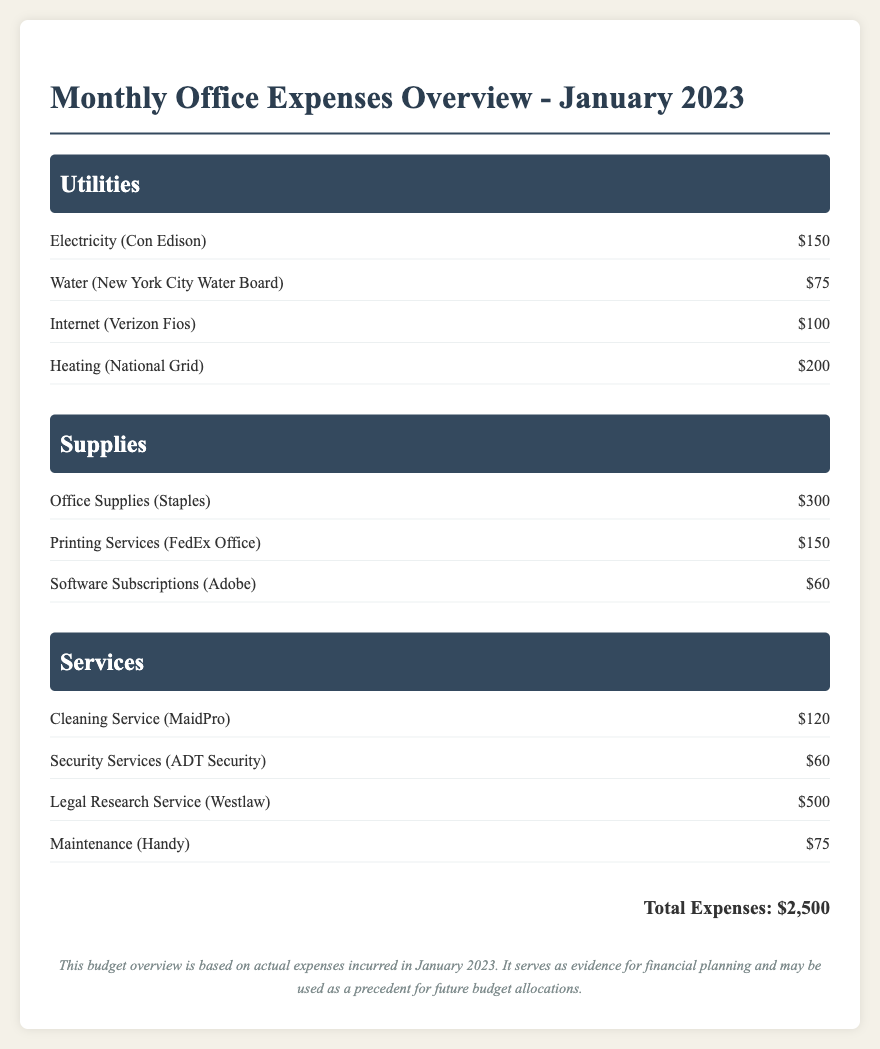What was the expense for electricity? The expense for electricity can be found listed under Utilities as $150.
Answer: $150 How much did the office spend on legal research services? The expenditure for legal research services is detailed under Services, which totals $500.
Answer: $500 What is the total amount spent on supplies? The total for supplies can be calculated by adding all items listed under that section: $300 + $150 + $60 = $510.
Answer: $510 Which utility had the highest expense? The utilities section shows that Heating (National Grid) has the highest expense of $200.
Answer: $200 How much did the office pay for cleaning services? Cleaning Service (MaidPro) shows an expense of $120 in the Services section.
Answer: $120 What is the total expense for January 2023? The total expenses listed at the end of the document sums up to $2,500.
Answer: $2,500 What was the cost of internet services? The document lists the cost of Internet (Verizon Fios) at $100 under the Utilities section.
Answer: $100 How many service items are listed? There are four service items detailed under the Services section of the document.
Answer: Four What agency provides the water services? The document states that the water services are provided by the New York City Water Board.
Answer: New York City Water Board 